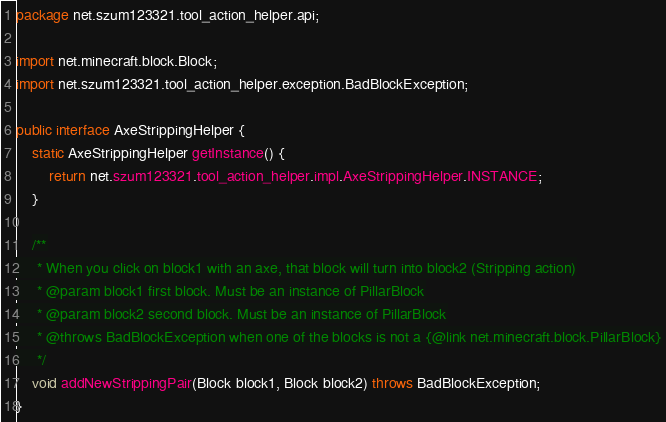<code> <loc_0><loc_0><loc_500><loc_500><_Java_>package net.szum123321.tool_action_helper.api;

import net.minecraft.block.Block;
import net.szum123321.tool_action_helper.exception.BadBlockException;

public interface AxeStrippingHelper {
    static AxeStrippingHelper getInstance() {
        return net.szum123321.tool_action_helper.impl.AxeStrippingHelper.INSTANCE;
    }

    /**
     * When you click on block1 with an axe, that block will turn into block2 (Stripping action)
     * @param block1 first block. Must be an instance of PillarBlock
     * @param block2 second block. Must be an instance of PillarBlock
     * @throws BadBlockException when one of the blocks is not a {@link net.minecraft.block.PillarBlock}
     */
    void addNewStrippingPair(Block block1, Block block2) throws BadBlockException;
}
</code> 